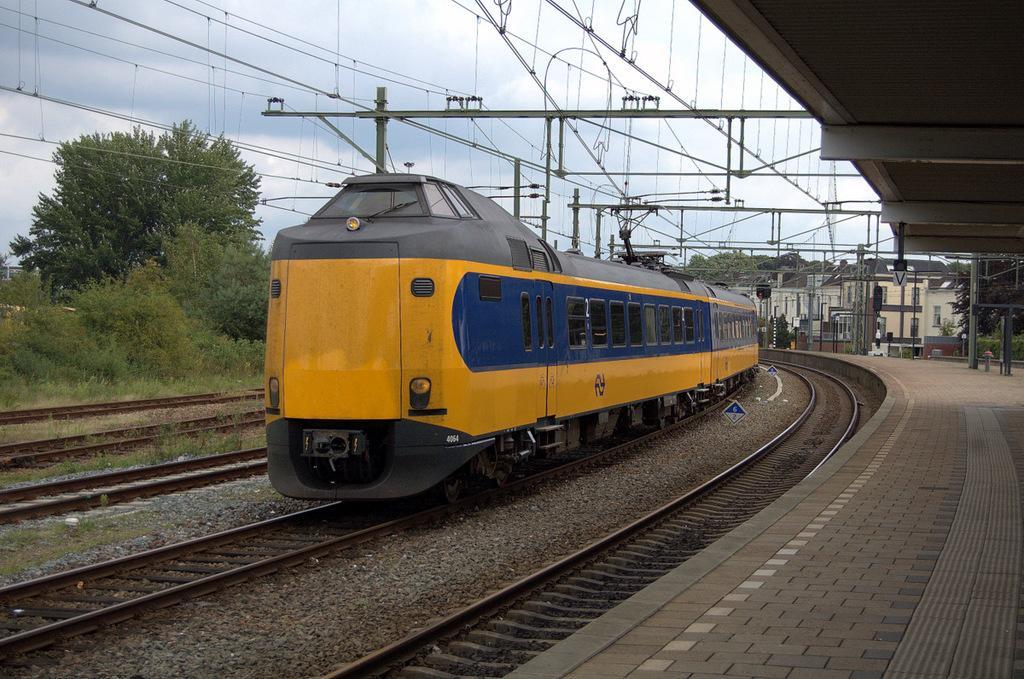How would you summarize this image in a sentence or two? In this picture we observe a yellow train which is on the track and in the background we observe trees and there are cables over the train. 